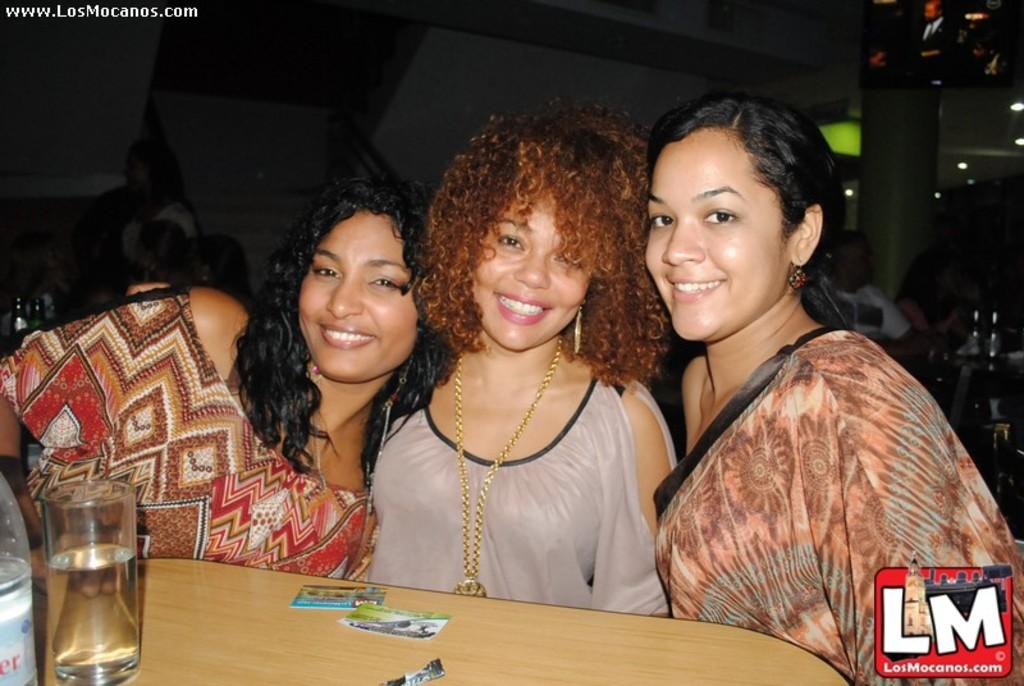How many women are present in the image? There are three women in the image. What is the appearance of the women in the image? The women are beautiful. What expression do the women have in the image? The women are smiling. What can be seen on the left side of the image? There is a wine glass on the table on the left side of the image. What is present on the right side of the image? There is a name on the right side of the image. Can you tell me how many times the women drop the wine glass in the image? There is no indication in the image that the women drop the wine glass; it is not mentioned in the facts provided. 